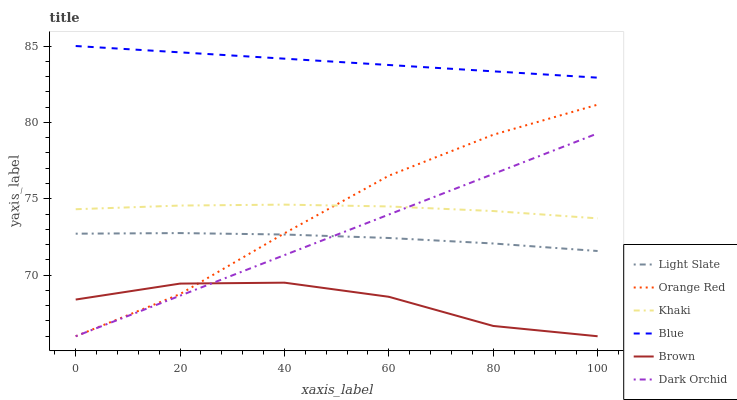Does Brown have the minimum area under the curve?
Answer yes or no. Yes. Does Blue have the maximum area under the curve?
Answer yes or no. Yes. Does Khaki have the minimum area under the curve?
Answer yes or no. No. Does Khaki have the maximum area under the curve?
Answer yes or no. No. Is Blue the smoothest?
Answer yes or no. Yes. Is Brown the roughest?
Answer yes or no. Yes. Is Khaki the smoothest?
Answer yes or no. No. Is Khaki the roughest?
Answer yes or no. No. Does Brown have the lowest value?
Answer yes or no. Yes. Does Khaki have the lowest value?
Answer yes or no. No. Does Blue have the highest value?
Answer yes or no. Yes. Does Khaki have the highest value?
Answer yes or no. No. Is Brown less than Khaki?
Answer yes or no. Yes. Is Khaki greater than Brown?
Answer yes or no. Yes. Does Orange Red intersect Light Slate?
Answer yes or no. Yes. Is Orange Red less than Light Slate?
Answer yes or no. No. Is Orange Red greater than Light Slate?
Answer yes or no. No. Does Brown intersect Khaki?
Answer yes or no. No. 